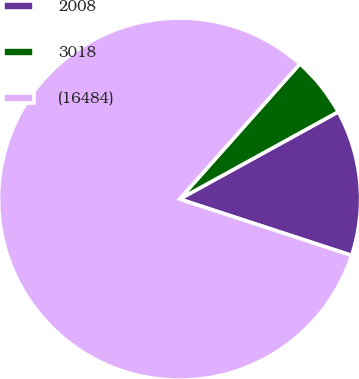<chart> <loc_0><loc_0><loc_500><loc_500><pie_chart><fcel>2008<fcel>3018<fcel>(16484)<nl><fcel>13.04%<fcel>5.43%<fcel>81.53%<nl></chart> 